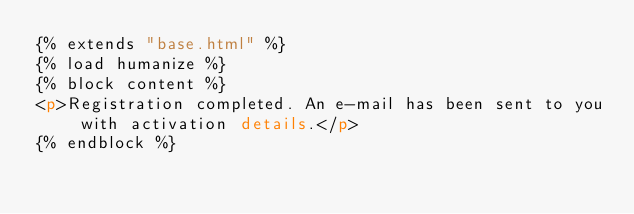Convert code to text. <code><loc_0><loc_0><loc_500><loc_500><_HTML_>{% extends "base.html" %}
{% load humanize %}
{% block content %}
<p>Registration completed. An e-mail has been sent to you with activation details.</p>
{% endblock %}

</code> 